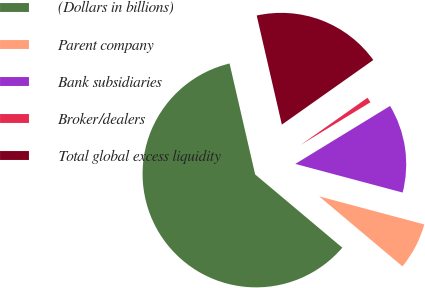<chart> <loc_0><loc_0><loc_500><loc_500><pie_chart><fcel>(Dollars in billions)<fcel>Parent company<fcel>Bank subsidiaries<fcel>Broker/dealers<fcel>Total global excess liquidity<nl><fcel>60.27%<fcel>6.97%<fcel>12.89%<fcel>1.05%<fcel>18.82%<nl></chart> 